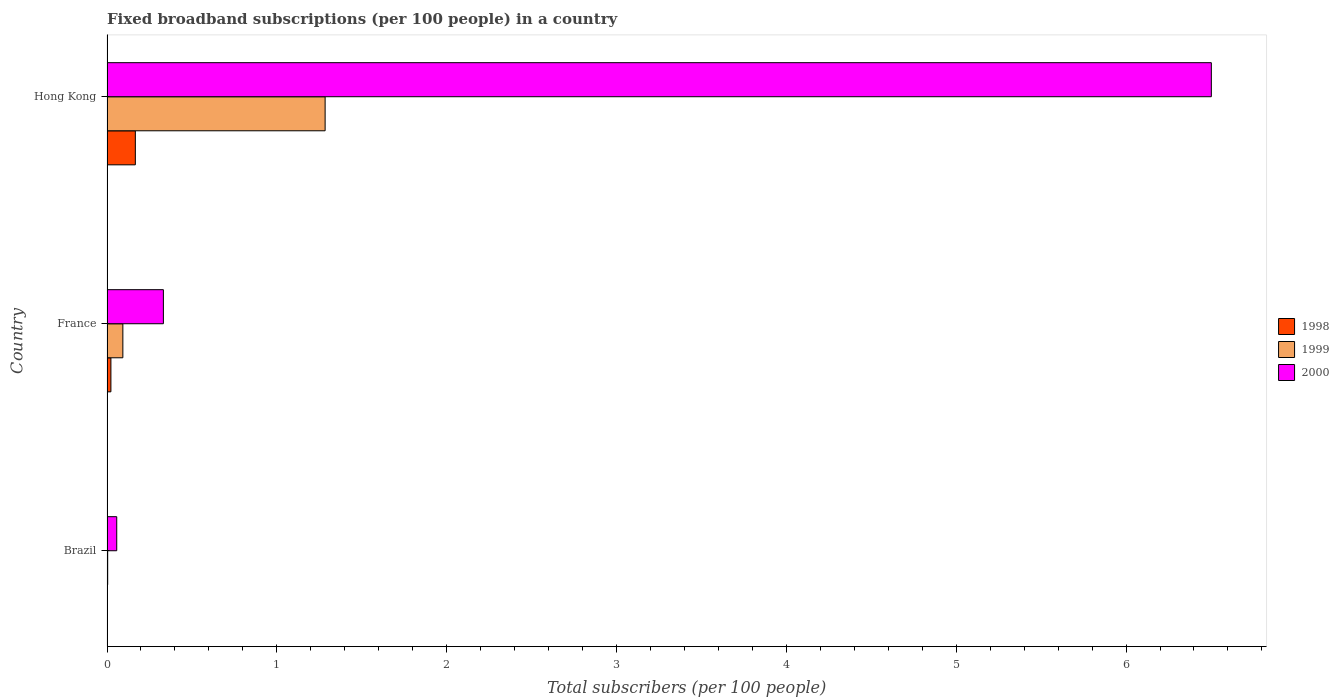How many groups of bars are there?
Give a very brief answer. 3. How many bars are there on the 1st tick from the bottom?
Offer a very short reply. 3. What is the label of the 1st group of bars from the top?
Give a very brief answer. Hong Kong. What is the number of broadband subscriptions in 2000 in Brazil?
Your answer should be very brief. 0.06. Across all countries, what is the maximum number of broadband subscriptions in 2000?
Your response must be concise. 6.5. Across all countries, what is the minimum number of broadband subscriptions in 1998?
Provide a succinct answer. 0. In which country was the number of broadband subscriptions in 2000 maximum?
Your answer should be compact. Hong Kong. What is the total number of broadband subscriptions in 2000 in the graph?
Your answer should be compact. 6.89. What is the difference between the number of broadband subscriptions in 1999 in Brazil and that in France?
Provide a short and direct response. -0.09. What is the difference between the number of broadband subscriptions in 2000 in Hong Kong and the number of broadband subscriptions in 1998 in France?
Keep it short and to the point. 6.48. What is the average number of broadband subscriptions in 1998 per country?
Offer a terse response. 0.06. What is the difference between the number of broadband subscriptions in 1999 and number of broadband subscriptions in 1998 in France?
Provide a short and direct response. 0.07. In how many countries, is the number of broadband subscriptions in 1999 greater than 2 ?
Your answer should be compact. 0. What is the ratio of the number of broadband subscriptions in 2000 in France to that in Hong Kong?
Your response must be concise. 0.05. Is the difference between the number of broadband subscriptions in 1999 in Brazil and France greater than the difference between the number of broadband subscriptions in 1998 in Brazil and France?
Provide a succinct answer. No. What is the difference between the highest and the second highest number of broadband subscriptions in 1999?
Ensure brevity in your answer.  1.19. What is the difference between the highest and the lowest number of broadband subscriptions in 1998?
Offer a very short reply. 0.17. In how many countries, is the number of broadband subscriptions in 1999 greater than the average number of broadband subscriptions in 1999 taken over all countries?
Make the answer very short. 1. Is the sum of the number of broadband subscriptions in 1999 in Brazil and Hong Kong greater than the maximum number of broadband subscriptions in 1998 across all countries?
Give a very brief answer. Yes. What does the 1st bar from the top in France represents?
Provide a succinct answer. 2000. What does the 1st bar from the bottom in Hong Kong represents?
Offer a terse response. 1998. Is it the case that in every country, the sum of the number of broadband subscriptions in 1998 and number of broadband subscriptions in 2000 is greater than the number of broadband subscriptions in 1999?
Your answer should be compact. Yes. How many countries are there in the graph?
Offer a very short reply. 3. Are the values on the major ticks of X-axis written in scientific E-notation?
Your answer should be very brief. No. Does the graph contain grids?
Ensure brevity in your answer.  No. How many legend labels are there?
Provide a succinct answer. 3. How are the legend labels stacked?
Your answer should be very brief. Vertical. What is the title of the graph?
Give a very brief answer. Fixed broadband subscriptions (per 100 people) in a country. What is the label or title of the X-axis?
Ensure brevity in your answer.  Total subscribers (per 100 people). What is the label or title of the Y-axis?
Provide a short and direct response. Country. What is the Total subscribers (per 100 people) in 1998 in Brazil?
Make the answer very short. 0. What is the Total subscribers (per 100 people) of 1999 in Brazil?
Ensure brevity in your answer.  0. What is the Total subscribers (per 100 people) of 2000 in Brazil?
Offer a very short reply. 0.06. What is the Total subscribers (per 100 people) in 1998 in France?
Your response must be concise. 0.02. What is the Total subscribers (per 100 people) of 1999 in France?
Your answer should be very brief. 0.09. What is the Total subscribers (per 100 people) of 2000 in France?
Provide a short and direct response. 0.33. What is the Total subscribers (per 100 people) of 1998 in Hong Kong?
Provide a short and direct response. 0.17. What is the Total subscribers (per 100 people) of 1999 in Hong Kong?
Ensure brevity in your answer.  1.28. What is the Total subscribers (per 100 people) in 2000 in Hong Kong?
Your answer should be compact. 6.5. Across all countries, what is the maximum Total subscribers (per 100 people) of 1998?
Offer a very short reply. 0.17. Across all countries, what is the maximum Total subscribers (per 100 people) of 1999?
Give a very brief answer. 1.28. Across all countries, what is the maximum Total subscribers (per 100 people) of 2000?
Your answer should be very brief. 6.5. Across all countries, what is the minimum Total subscribers (per 100 people) of 1998?
Offer a terse response. 0. Across all countries, what is the minimum Total subscribers (per 100 people) in 1999?
Your answer should be very brief. 0. Across all countries, what is the minimum Total subscribers (per 100 people) in 2000?
Make the answer very short. 0.06. What is the total Total subscribers (per 100 people) of 1998 in the graph?
Your answer should be very brief. 0.19. What is the total Total subscribers (per 100 people) of 1999 in the graph?
Provide a succinct answer. 1.38. What is the total Total subscribers (per 100 people) of 2000 in the graph?
Make the answer very short. 6.89. What is the difference between the Total subscribers (per 100 people) of 1998 in Brazil and that in France?
Keep it short and to the point. -0.02. What is the difference between the Total subscribers (per 100 people) in 1999 in Brazil and that in France?
Keep it short and to the point. -0.09. What is the difference between the Total subscribers (per 100 people) in 2000 in Brazil and that in France?
Ensure brevity in your answer.  -0.27. What is the difference between the Total subscribers (per 100 people) of 1998 in Brazil and that in Hong Kong?
Your answer should be compact. -0.17. What is the difference between the Total subscribers (per 100 people) of 1999 in Brazil and that in Hong Kong?
Your response must be concise. -1.28. What is the difference between the Total subscribers (per 100 people) in 2000 in Brazil and that in Hong Kong?
Your response must be concise. -6.45. What is the difference between the Total subscribers (per 100 people) in 1998 in France and that in Hong Kong?
Offer a terse response. -0.14. What is the difference between the Total subscribers (per 100 people) in 1999 in France and that in Hong Kong?
Provide a succinct answer. -1.19. What is the difference between the Total subscribers (per 100 people) in 2000 in France and that in Hong Kong?
Your answer should be very brief. -6.17. What is the difference between the Total subscribers (per 100 people) of 1998 in Brazil and the Total subscribers (per 100 people) of 1999 in France?
Offer a terse response. -0.09. What is the difference between the Total subscribers (per 100 people) of 1998 in Brazil and the Total subscribers (per 100 people) of 2000 in France?
Offer a terse response. -0.33. What is the difference between the Total subscribers (per 100 people) in 1999 in Brazil and the Total subscribers (per 100 people) in 2000 in France?
Your answer should be compact. -0.33. What is the difference between the Total subscribers (per 100 people) of 1998 in Brazil and the Total subscribers (per 100 people) of 1999 in Hong Kong?
Ensure brevity in your answer.  -1.28. What is the difference between the Total subscribers (per 100 people) of 1998 in Brazil and the Total subscribers (per 100 people) of 2000 in Hong Kong?
Your answer should be compact. -6.5. What is the difference between the Total subscribers (per 100 people) in 1999 in Brazil and the Total subscribers (per 100 people) in 2000 in Hong Kong?
Make the answer very short. -6.5. What is the difference between the Total subscribers (per 100 people) of 1998 in France and the Total subscribers (per 100 people) of 1999 in Hong Kong?
Your answer should be compact. -1.26. What is the difference between the Total subscribers (per 100 people) in 1998 in France and the Total subscribers (per 100 people) in 2000 in Hong Kong?
Your answer should be very brief. -6.48. What is the difference between the Total subscribers (per 100 people) of 1999 in France and the Total subscribers (per 100 people) of 2000 in Hong Kong?
Provide a short and direct response. -6.41. What is the average Total subscribers (per 100 people) of 1998 per country?
Offer a very short reply. 0.06. What is the average Total subscribers (per 100 people) of 1999 per country?
Offer a very short reply. 0.46. What is the average Total subscribers (per 100 people) in 2000 per country?
Offer a very short reply. 2.3. What is the difference between the Total subscribers (per 100 people) of 1998 and Total subscribers (per 100 people) of 1999 in Brazil?
Make the answer very short. -0. What is the difference between the Total subscribers (per 100 people) in 1998 and Total subscribers (per 100 people) in 2000 in Brazil?
Your response must be concise. -0.06. What is the difference between the Total subscribers (per 100 people) in 1999 and Total subscribers (per 100 people) in 2000 in Brazil?
Your answer should be compact. -0.05. What is the difference between the Total subscribers (per 100 people) of 1998 and Total subscribers (per 100 people) of 1999 in France?
Keep it short and to the point. -0.07. What is the difference between the Total subscribers (per 100 people) of 1998 and Total subscribers (per 100 people) of 2000 in France?
Give a very brief answer. -0.31. What is the difference between the Total subscribers (per 100 people) in 1999 and Total subscribers (per 100 people) in 2000 in France?
Give a very brief answer. -0.24. What is the difference between the Total subscribers (per 100 people) of 1998 and Total subscribers (per 100 people) of 1999 in Hong Kong?
Give a very brief answer. -1.12. What is the difference between the Total subscribers (per 100 people) in 1998 and Total subscribers (per 100 people) in 2000 in Hong Kong?
Make the answer very short. -6.34. What is the difference between the Total subscribers (per 100 people) of 1999 and Total subscribers (per 100 people) of 2000 in Hong Kong?
Your response must be concise. -5.22. What is the ratio of the Total subscribers (per 100 people) of 1998 in Brazil to that in France?
Your answer should be very brief. 0.03. What is the ratio of the Total subscribers (per 100 people) of 1999 in Brazil to that in France?
Make the answer very short. 0.04. What is the ratio of the Total subscribers (per 100 people) in 2000 in Brazil to that in France?
Your answer should be very brief. 0.17. What is the ratio of the Total subscribers (per 100 people) of 1998 in Brazil to that in Hong Kong?
Give a very brief answer. 0. What is the ratio of the Total subscribers (per 100 people) in 1999 in Brazil to that in Hong Kong?
Make the answer very short. 0. What is the ratio of the Total subscribers (per 100 people) in 2000 in Brazil to that in Hong Kong?
Your response must be concise. 0.01. What is the ratio of the Total subscribers (per 100 people) of 1998 in France to that in Hong Kong?
Your answer should be compact. 0.14. What is the ratio of the Total subscribers (per 100 people) of 1999 in France to that in Hong Kong?
Your answer should be very brief. 0.07. What is the ratio of the Total subscribers (per 100 people) in 2000 in France to that in Hong Kong?
Offer a terse response. 0.05. What is the difference between the highest and the second highest Total subscribers (per 100 people) in 1998?
Provide a short and direct response. 0.14. What is the difference between the highest and the second highest Total subscribers (per 100 people) of 1999?
Your answer should be very brief. 1.19. What is the difference between the highest and the second highest Total subscribers (per 100 people) in 2000?
Give a very brief answer. 6.17. What is the difference between the highest and the lowest Total subscribers (per 100 people) in 1998?
Ensure brevity in your answer.  0.17. What is the difference between the highest and the lowest Total subscribers (per 100 people) of 1999?
Your answer should be compact. 1.28. What is the difference between the highest and the lowest Total subscribers (per 100 people) of 2000?
Offer a very short reply. 6.45. 